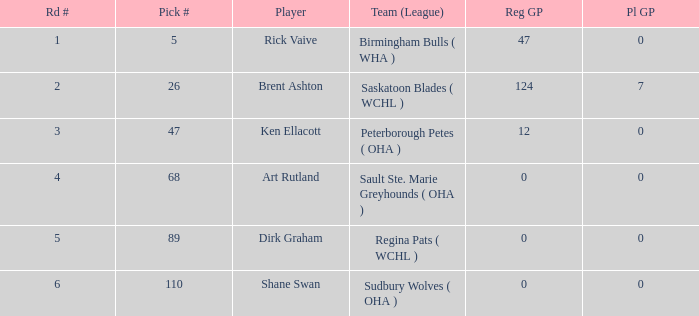How many reg GP for rick vaive in round 1? None. 